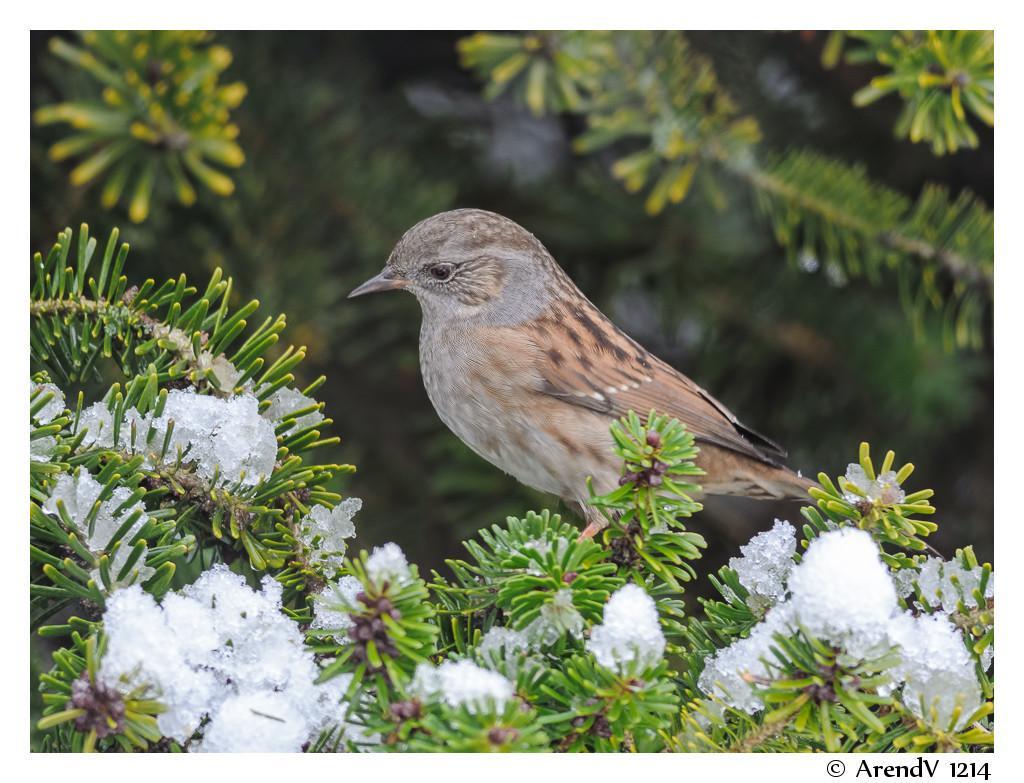Describe this image in one or two sentences. In this picture we can see small brown color bird is sitting on the green plants. Behind there is a blur background. 